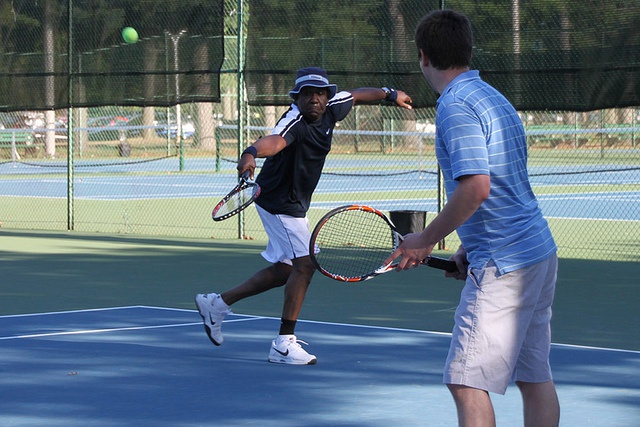Describe the objects in this image and their specific colors. I can see people in black, gray, blue, and lavender tones, people in black, gray, navy, and lavender tones, tennis racket in black, blue, darkgray, and gray tones, car in black, darkgray, gray, and lightgray tones, and tennis racket in black, darkgray, lightblue, and gray tones in this image. 